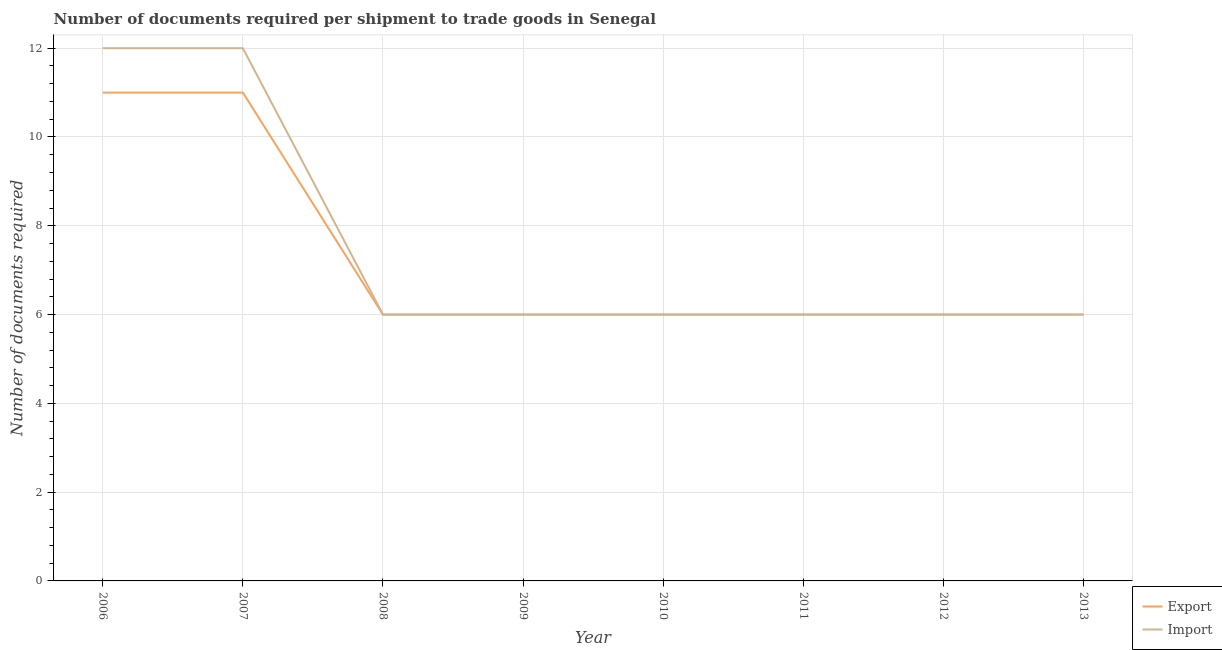How many different coloured lines are there?
Ensure brevity in your answer.  2. What is the number of documents required to import goods in 2008?
Your answer should be very brief. 6. Across all years, what is the maximum number of documents required to export goods?
Offer a very short reply. 11. Across all years, what is the minimum number of documents required to export goods?
Make the answer very short. 6. What is the total number of documents required to import goods in the graph?
Provide a succinct answer. 60. What is the difference between the number of documents required to export goods in 2007 and that in 2010?
Keep it short and to the point. 5. What is the average number of documents required to export goods per year?
Your answer should be very brief. 7.25. In the year 2006, what is the difference between the number of documents required to export goods and number of documents required to import goods?
Offer a terse response. -1. What is the ratio of the number of documents required to import goods in 2011 to that in 2013?
Offer a terse response. 1. Is the number of documents required to import goods in 2008 less than that in 2013?
Ensure brevity in your answer.  No. What is the difference between the highest and the second highest number of documents required to import goods?
Keep it short and to the point. 0. What is the difference between the highest and the lowest number of documents required to import goods?
Make the answer very short. 6. Is the number of documents required to export goods strictly greater than the number of documents required to import goods over the years?
Your response must be concise. No. How many years are there in the graph?
Your answer should be very brief. 8. Are the values on the major ticks of Y-axis written in scientific E-notation?
Your answer should be very brief. No. Does the graph contain grids?
Provide a short and direct response. Yes. How many legend labels are there?
Provide a succinct answer. 2. How are the legend labels stacked?
Your answer should be very brief. Vertical. What is the title of the graph?
Offer a very short reply. Number of documents required per shipment to trade goods in Senegal. Does "Diarrhea" appear as one of the legend labels in the graph?
Make the answer very short. No. What is the label or title of the Y-axis?
Your answer should be very brief. Number of documents required. What is the Number of documents required of Export in 2006?
Your answer should be compact. 11. What is the Number of documents required of Export in 2007?
Keep it short and to the point. 11. What is the Number of documents required of Import in 2008?
Your answer should be compact. 6. What is the Number of documents required of Export in 2009?
Provide a succinct answer. 6. What is the Number of documents required of Export in 2010?
Give a very brief answer. 6. What is the Number of documents required in Export in 2011?
Offer a very short reply. 6. What is the Number of documents required in Import in 2011?
Ensure brevity in your answer.  6. Across all years, what is the maximum Number of documents required in Export?
Your answer should be compact. 11. Across all years, what is the maximum Number of documents required in Import?
Ensure brevity in your answer.  12. Across all years, what is the minimum Number of documents required in Export?
Offer a terse response. 6. What is the total Number of documents required of Export in the graph?
Offer a terse response. 58. What is the total Number of documents required of Import in the graph?
Provide a short and direct response. 60. What is the difference between the Number of documents required of Export in 2006 and that in 2007?
Give a very brief answer. 0. What is the difference between the Number of documents required of Import in 2006 and that in 2008?
Your answer should be compact. 6. What is the difference between the Number of documents required in Import in 2006 and that in 2009?
Your answer should be compact. 6. What is the difference between the Number of documents required in Export in 2006 and that in 2010?
Give a very brief answer. 5. What is the difference between the Number of documents required in Export in 2006 and that in 2011?
Give a very brief answer. 5. What is the difference between the Number of documents required in Import in 2006 and that in 2011?
Ensure brevity in your answer.  6. What is the difference between the Number of documents required of Import in 2006 and that in 2012?
Give a very brief answer. 6. What is the difference between the Number of documents required in Import in 2006 and that in 2013?
Ensure brevity in your answer.  6. What is the difference between the Number of documents required of Export in 2007 and that in 2008?
Provide a short and direct response. 5. What is the difference between the Number of documents required in Export in 2007 and that in 2010?
Offer a terse response. 5. What is the difference between the Number of documents required in Import in 2007 and that in 2010?
Make the answer very short. 6. What is the difference between the Number of documents required in Export in 2007 and that in 2011?
Provide a succinct answer. 5. What is the difference between the Number of documents required of Import in 2007 and that in 2012?
Provide a short and direct response. 6. What is the difference between the Number of documents required of Export in 2007 and that in 2013?
Your response must be concise. 5. What is the difference between the Number of documents required of Export in 2008 and that in 2009?
Make the answer very short. 0. What is the difference between the Number of documents required of Import in 2008 and that in 2009?
Ensure brevity in your answer.  0. What is the difference between the Number of documents required in Export in 2008 and that in 2010?
Ensure brevity in your answer.  0. What is the difference between the Number of documents required in Import in 2008 and that in 2010?
Your response must be concise. 0. What is the difference between the Number of documents required of Import in 2008 and that in 2011?
Make the answer very short. 0. What is the difference between the Number of documents required in Export in 2008 and that in 2013?
Your response must be concise. 0. What is the difference between the Number of documents required in Import in 2008 and that in 2013?
Your answer should be compact. 0. What is the difference between the Number of documents required in Export in 2009 and that in 2012?
Offer a terse response. 0. What is the difference between the Number of documents required of Import in 2011 and that in 2012?
Provide a succinct answer. 0. What is the difference between the Number of documents required of Export in 2011 and that in 2013?
Your answer should be very brief. 0. What is the difference between the Number of documents required of Export in 2006 and the Number of documents required of Import in 2008?
Provide a succinct answer. 5. What is the difference between the Number of documents required in Export in 2006 and the Number of documents required in Import in 2009?
Give a very brief answer. 5. What is the difference between the Number of documents required of Export in 2006 and the Number of documents required of Import in 2011?
Your answer should be very brief. 5. What is the difference between the Number of documents required in Export in 2007 and the Number of documents required in Import in 2008?
Ensure brevity in your answer.  5. What is the difference between the Number of documents required in Export in 2007 and the Number of documents required in Import in 2009?
Provide a succinct answer. 5. What is the difference between the Number of documents required in Export in 2007 and the Number of documents required in Import in 2010?
Offer a terse response. 5. What is the difference between the Number of documents required of Export in 2007 and the Number of documents required of Import in 2011?
Give a very brief answer. 5. What is the difference between the Number of documents required of Export in 2008 and the Number of documents required of Import in 2009?
Keep it short and to the point. 0. What is the difference between the Number of documents required in Export in 2008 and the Number of documents required in Import in 2012?
Your answer should be compact. 0. What is the difference between the Number of documents required in Export in 2008 and the Number of documents required in Import in 2013?
Ensure brevity in your answer.  0. What is the difference between the Number of documents required of Export in 2009 and the Number of documents required of Import in 2010?
Give a very brief answer. 0. What is the difference between the Number of documents required in Export in 2009 and the Number of documents required in Import in 2013?
Your response must be concise. 0. What is the difference between the Number of documents required of Export in 2010 and the Number of documents required of Import in 2012?
Make the answer very short. 0. What is the difference between the Number of documents required of Export in 2010 and the Number of documents required of Import in 2013?
Offer a very short reply. 0. What is the difference between the Number of documents required in Export in 2011 and the Number of documents required in Import in 2012?
Offer a terse response. 0. What is the difference between the Number of documents required in Export in 2012 and the Number of documents required in Import in 2013?
Give a very brief answer. 0. What is the average Number of documents required in Export per year?
Offer a terse response. 7.25. In the year 2010, what is the difference between the Number of documents required in Export and Number of documents required in Import?
Ensure brevity in your answer.  0. In the year 2011, what is the difference between the Number of documents required of Export and Number of documents required of Import?
Your answer should be compact. 0. In the year 2012, what is the difference between the Number of documents required in Export and Number of documents required in Import?
Offer a very short reply. 0. What is the ratio of the Number of documents required of Export in 2006 to that in 2007?
Provide a short and direct response. 1. What is the ratio of the Number of documents required in Export in 2006 to that in 2008?
Give a very brief answer. 1.83. What is the ratio of the Number of documents required in Export in 2006 to that in 2009?
Give a very brief answer. 1.83. What is the ratio of the Number of documents required of Export in 2006 to that in 2010?
Ensure brevity in your answer.  1.83. What is the ratio of the Number of documents required in Import in 2006 to that in 2010?
Your answer should be compact. 2. What is the ratio of the Number of documents required of Export in 2006 to that in 2011?
Offer a terse response. 1.83. What is the ratio of the Number of documents required of Export in 2006 to that in 2012?
Make the answer very short. 1.83. What is the ratio of the Number of documents required of Export in 2006 to that in 2013?
Offer a terse response. 1.83. What is the ratio of the Number of documents required of Export in 2007 to that in 2008?
Provide a short and direct response. 1.83. What is the ratio of the Number of documents required of Import in 2007 to that in 2008?
Your answer should be very brief. 2. What is the ratio of the Number of documents required of Export in 2007 to that in 2009?
Offer a very short reply. 1.83. What is the ratio of the Number of documents required in Export in 2007 to that in 2010?
Provide a short and direct response. 1.83. What is the ratio of the Number of documents required of Export in 2007 to that in 2011?
Offer a terse response. 1.83. What is the ratio of the Number of documents required of Import in 2007 to that in 2011?
Make the answer very short. 2. What is the ratio of the Number of documents required in Export in 2007 to that in 2012?
Ensure brevity in your answer.  1.83. What is the ratio of the Number of documents required in Import in 2007 to that in 2012?
Your response must be concise. 2. What is the ratio of the Number of documents required in Export in 2007 to that in 2013?
Offer a very short reply. 1.83. What is the ratio of the Number of documents required in Import in 2007 to that in 2013?
Offer a very short reply. 2. What is the ratio of the Number of documents required of Import in 2008 to that in 2012?
Offer a very short reply. 1. What is the ratio of the Number of documents required of Export in 2008 to that in 2013?
Offer a very short reply. 1. What is the ratio of the Number of documents required of Import in 2008 to that in 2013?
Offer a very short reply. 1. What is the ratio of the Number of documents required in Import in 2009 to that in 2011?
Offer a terse response. 1. What is the ratio of the Number of documents required in Import in 2009 to that in 2013?
Make the answer very short. 1. What is the ratio of the Number of documents required of Export in 2010 to that in 2011?
Your answer should be compact. 1. What is the ratio of the Number of documents required of Export in 2011 to that in 2012?
Keep it short and to the point. 1. What is the ratio of the Number of documents required of Import in 2011 to that in 2012?
Make the answer very short. 1. What is the ratio of the Number of documents required in Import in 2012 to that in 2013?
Make the answer very short. 1. What is the difference between the highest and the lowest Number of documents required in Import?
Offer a terse response. 6. 